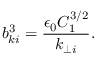Convert formula to latex. <formula><loc_0><loc_0><loc_500><loc_500>b _ { k i } ^ { 3 } = \frac { \epsilon _ { 0 } C _ { 1 } ^ { 3 / 2 } } { k _ { \perp i } } .</formula> 